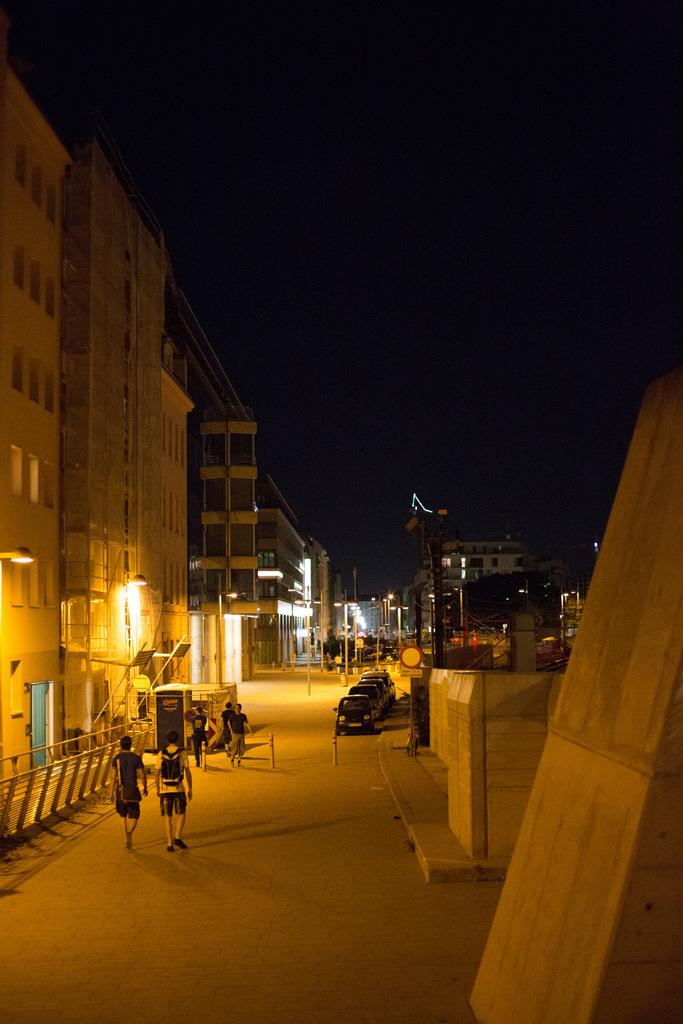What type of structures can be seen in the image? There are buildings with windows in the image. Who or what else is present in the image? There are people and vehicles in the image. What other objects can be seen in the image? There are light poles in the image. What part of the natural environment is visible in the image? The sky is visible in the image. Can you tell me how many bees are flying around the light poles in the image? There are no bees present in the image; the light poles are the only objects mentioned in the facts. 